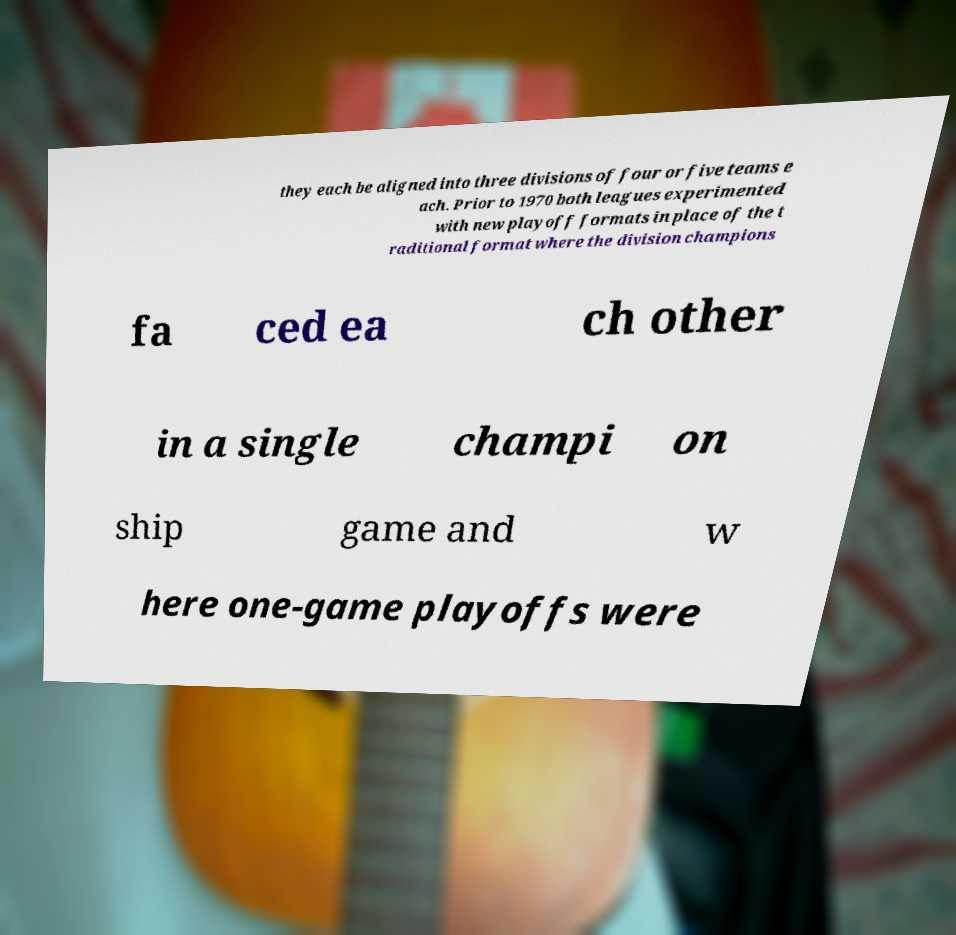For documentation purposes, I need the text within this image transcribed. Could you provide that? they each be aligned into three divisions of four or five teams e ach. Prior to 1970 both leagues experimented with new playoff formats in place of the t raditional format where the division champions fa ced ea ch other in a single champi on ship game and w here one-game playoffs were 